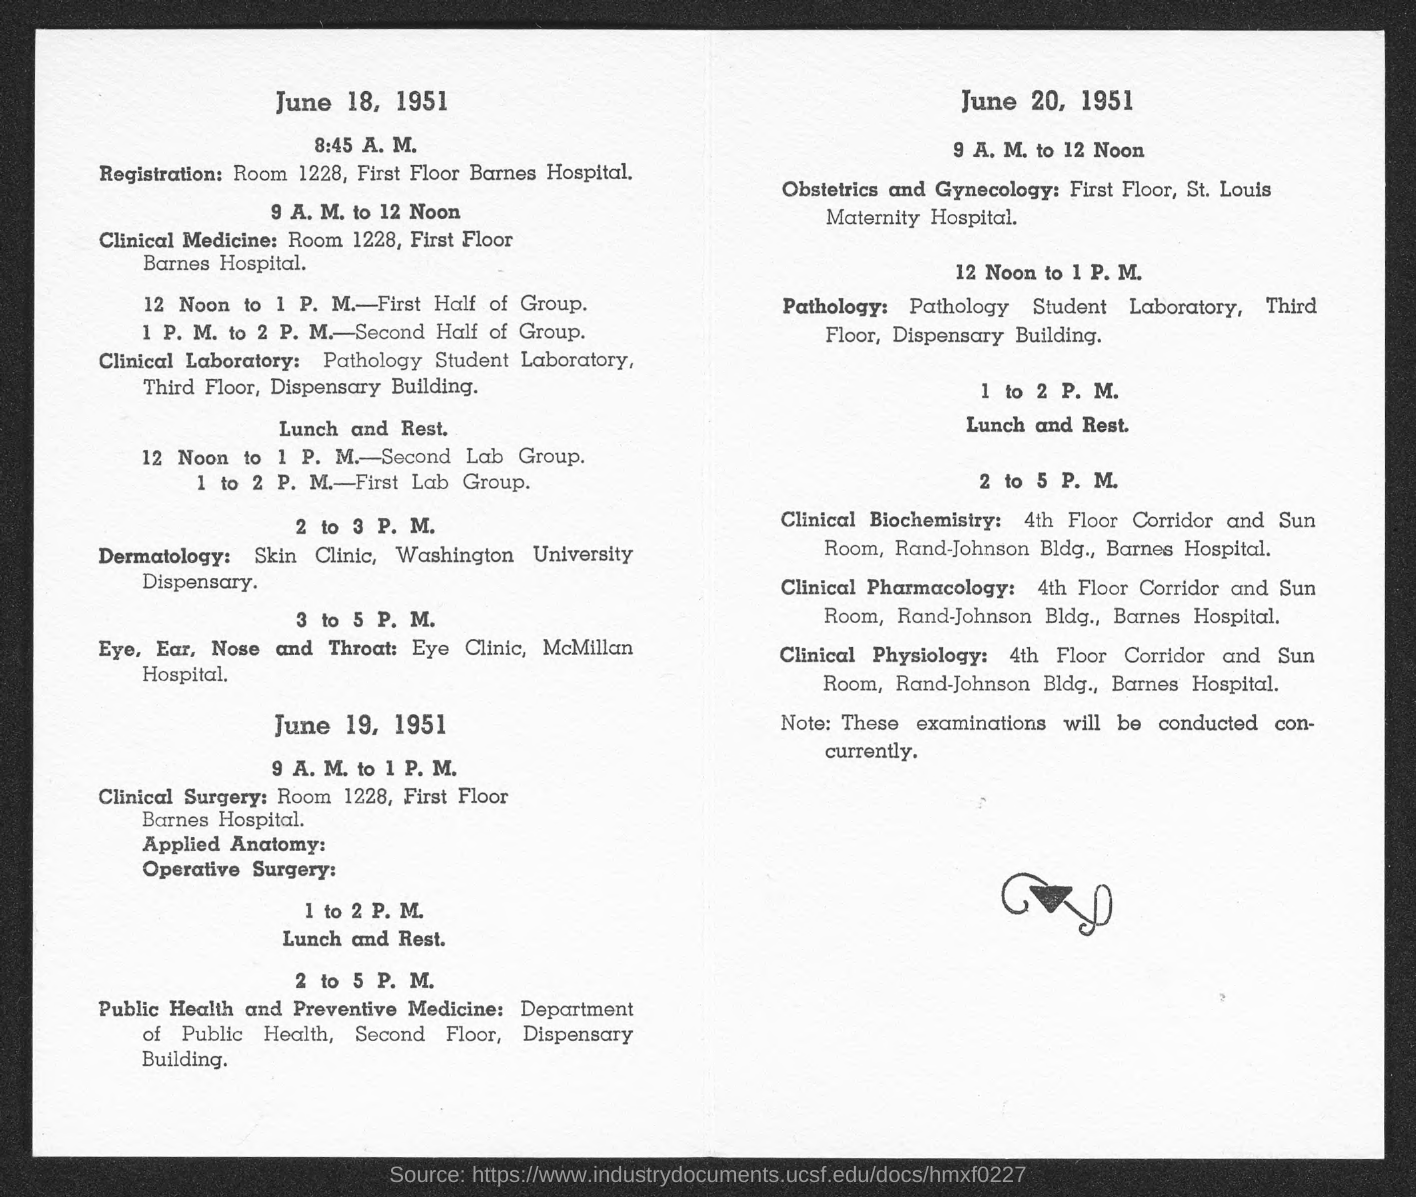Give some essential details in this illustration. Clinical pharmacology is located on the 4th floor. The pathology is located at the Dispensary Building. 